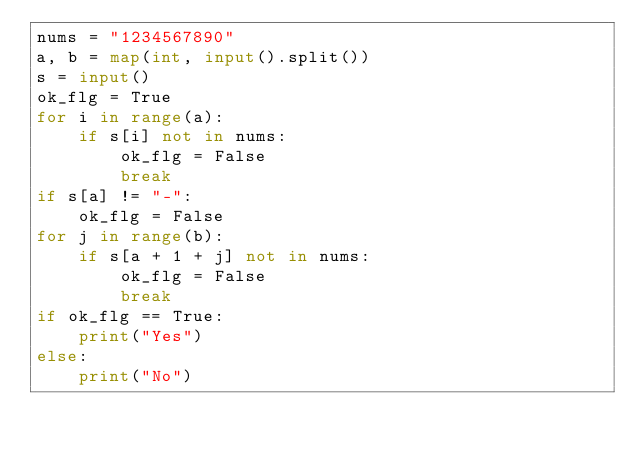Convert code to text. <code><loc_0><loc_0><loc_500><loc_500><_Python_>nums = "1234567890"
a, b = map(int, input().split())
s = input()
ok_flg = True
for i in range(a):
    if s[i] not in nums:
        ok_flg = False
        break
if s[a] != "-":
    ok_flg = False
for j in range(b):
    if s[a + 1 + j] not in nums:
        ok_flg = False
        break
if ok_flg == True:
    print("Yes")
else:
    print("No")
</code> 